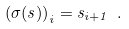<formula> <loc_0><loc_0><loc_500><loc_500>\left ( \sigma ( s ) \right ) _ { i } = s _ { i + 1 } \ .</formula> 